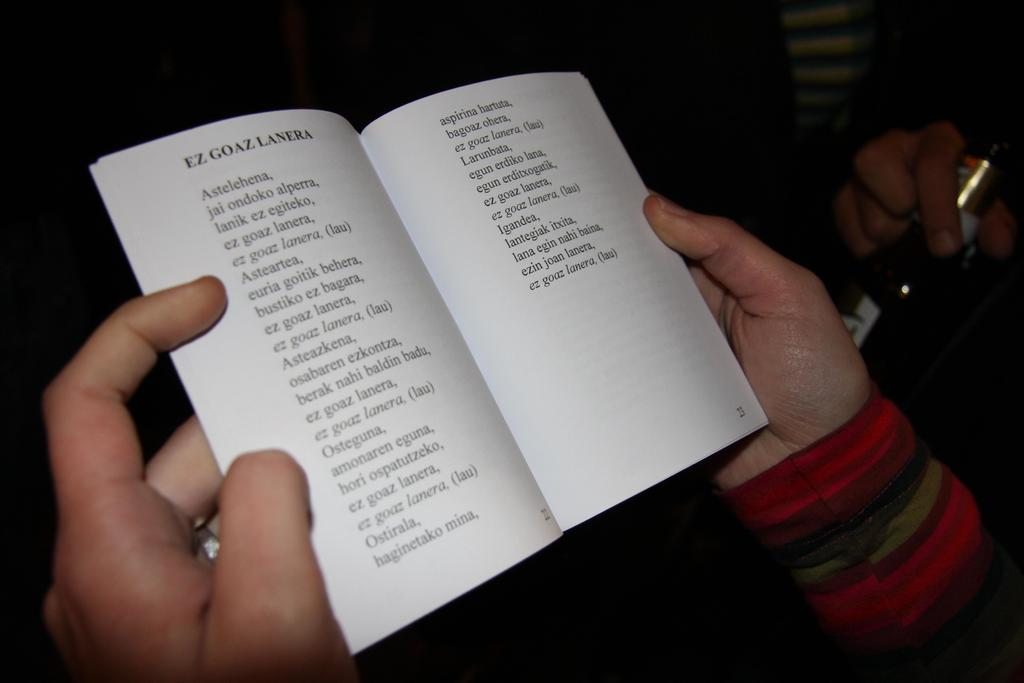<image>
Relay a brief, clear account of the picture shown. A person holds open a book which has Ez Goaz Lanera written on the left hand page. 